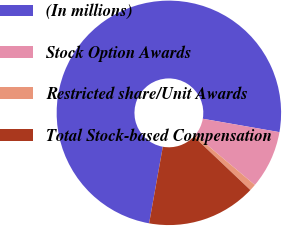Convert chart. <chart><loc_0><loc_0><loc_500><loc_500><pie_chart><fcel>(In millions)<fcel>Stock Option Awards<fcel>Restricted share/Unit Awards<fcel>Total Stock-based Compensation<nl><fcel>74.93%<fcel>8.36%<fcel>0.96%<fcel>15.75%<nl></chart> 